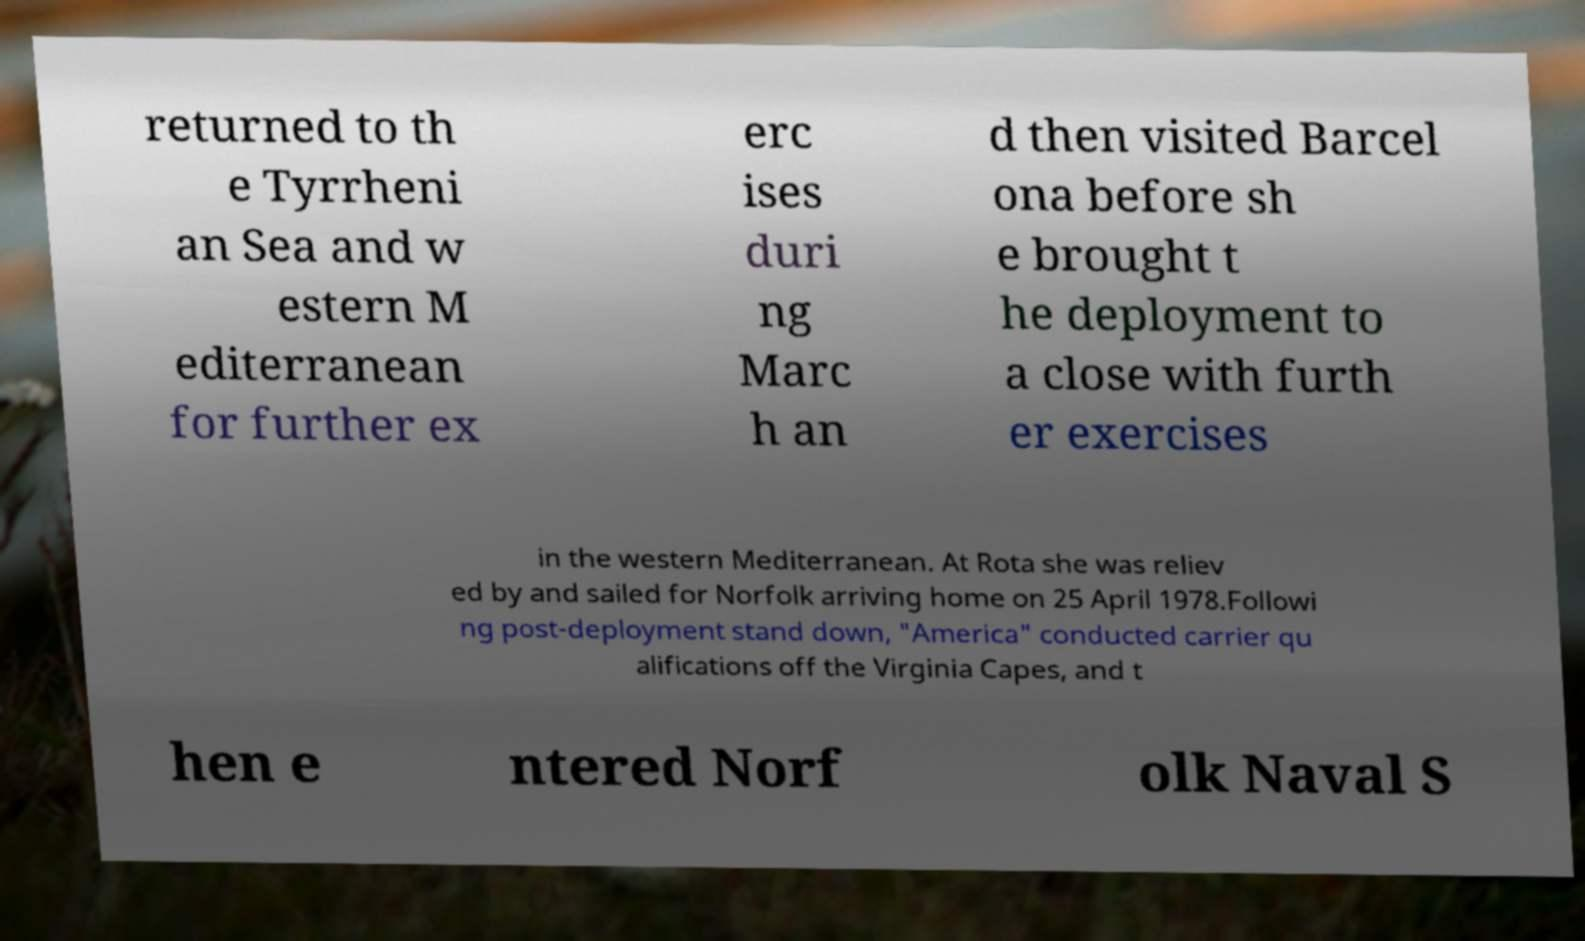Please identify and transcribe the text found in this image. returned to th e Tyrrheni an Sea and w estern M editerranean for further ex erc ises duri ng Marc h an d then visited Barcel ona before sh e brought t he deployment to a close with furth er exercises in the western Mediterranean. At Rota she was reliev ed by and sailed for Norfolk arriving home on 25 April 1978.Followi ng post-deployment stand down, "America" conducted carrier qu alifications off the Virginia Capes, and t hen e ntered Norf olk Naval S 